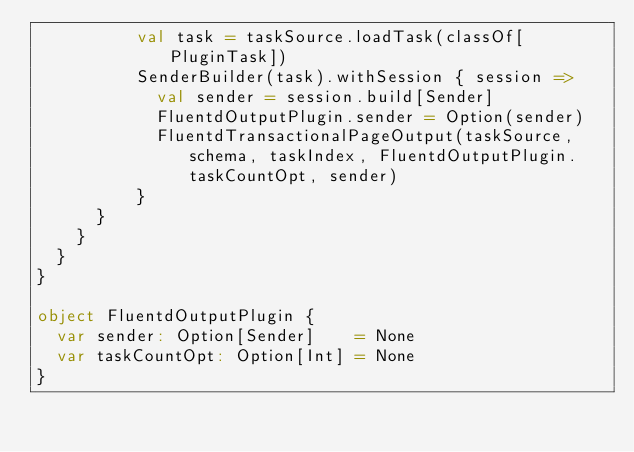<code> <loc_0><loc_0><loc_500><loc_500><_Scala_>          val task = taskSource.loadTask(classOf[PluginTask])
          SenderBuilder(task).withSession { session =>
            val sender = session.build[Sender]
            FluentdOutputPlugin.sender = Option(sender)
            FluentdTransactionalPageOutput(taskSource, schema, taskIndex, FluentdOutputPlugin.taskCountOpt, sender)
          }
      }
    }
  }
}

object FluentdOutputPlugin {
  var sender: Option[Sender]    = None
  var taskCountOpt: Option[Int] = None
}
</code> 